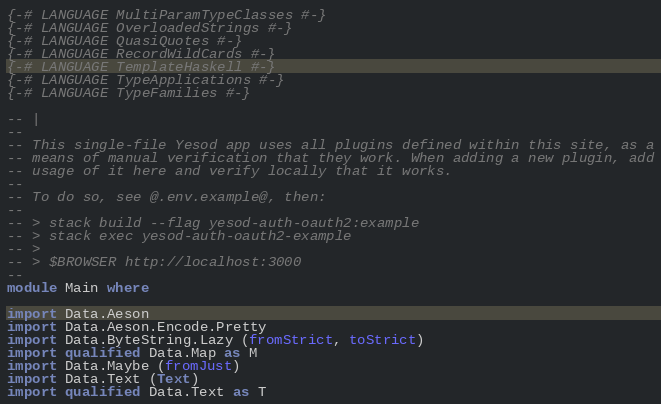<code> <loc_0><loc_0><loc_500><loc_500><_Haskell_>{-# LANGUAGE MultiParamTypeClasses #-}
{-# LANGUAGE OverloadedStrings #-}
{-# LANGUAGE QuasiQuotes #-}
{-# LANGUAGE RecordWildCards #-}
{-# LANGUAGE TemplateHaskell #-}
{-# LANGUAGE TypeApplications #-}
{-# LANGUAGE TypeFamilies #-}

-- |
--
-- This single-file Yesod app uses all plugins defined within this site, as a
-- means of manual verification that they work. When adding a new plugin, add
-- usage of it here and verify locally that it works.
--
-- To do so, see @.env.example@, then:
--
-- > stack build --flag yesod-auth-oauth2:example
-- > stack exec yesod-auth-oauth2-example
-- >
-- > $BROWSER http://localhost:3000
--
module Main where

import Data.Aeson
import Data.Aeson.Encode.Pretty
import Data.ByteString.Lazy (fromStrict, toStrict)
import qualified Data.Map as M
import Data.Maybe (fromJust)
import Data.Text (Text)
import qualified Data.Text as T</code> 